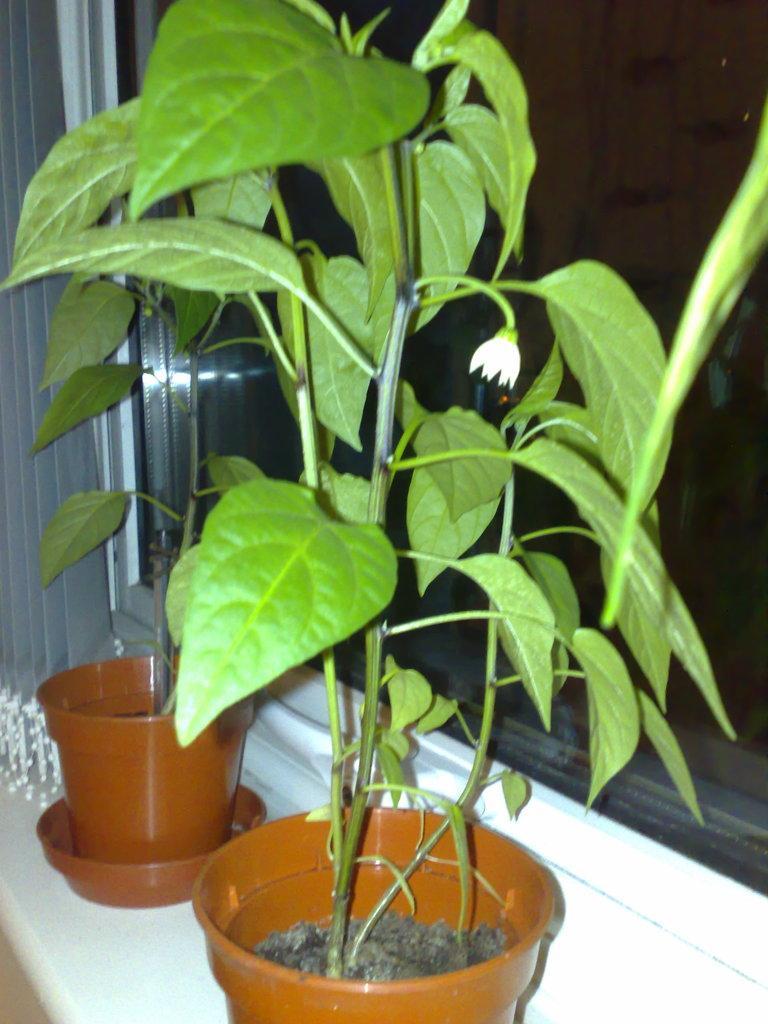Describe this image in one or two sentences. In the foreground of the picture we can see plants, flower pots and window. On the left it is window blind. 